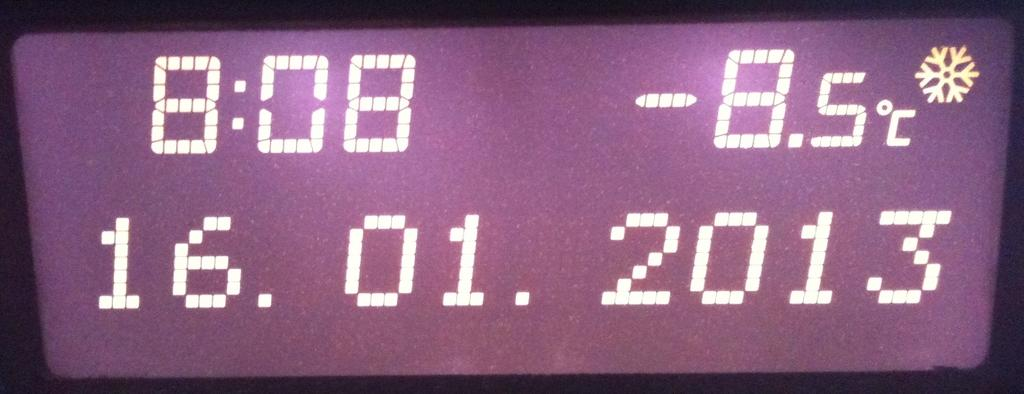<image>
Write a terse but informative summary of the picture. A digital display says the time is 8:08 and it's below freezing outside. 